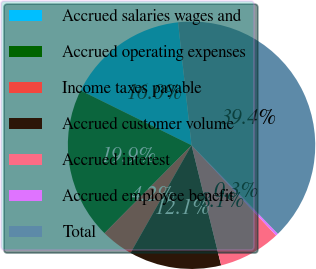Convert chart to OTSL. <chart><loc_0><loc_0><loc_500><loc_500><pie_chart><fcel>Accrued salaries wages and<fcel>Accrued operating expenses<fcel>Income taxes payable<fcel>Accrued customer volume<fcel>Accrued interest<fcel>Accrued employee benefit<fcel>Total<nl><fcel>15.96%<fcel>19.88%<fcel>4.22%<fcel>12.05%<fcel>8.14%<fcel>0.31%<fcel>39.44%<nl></chart> 